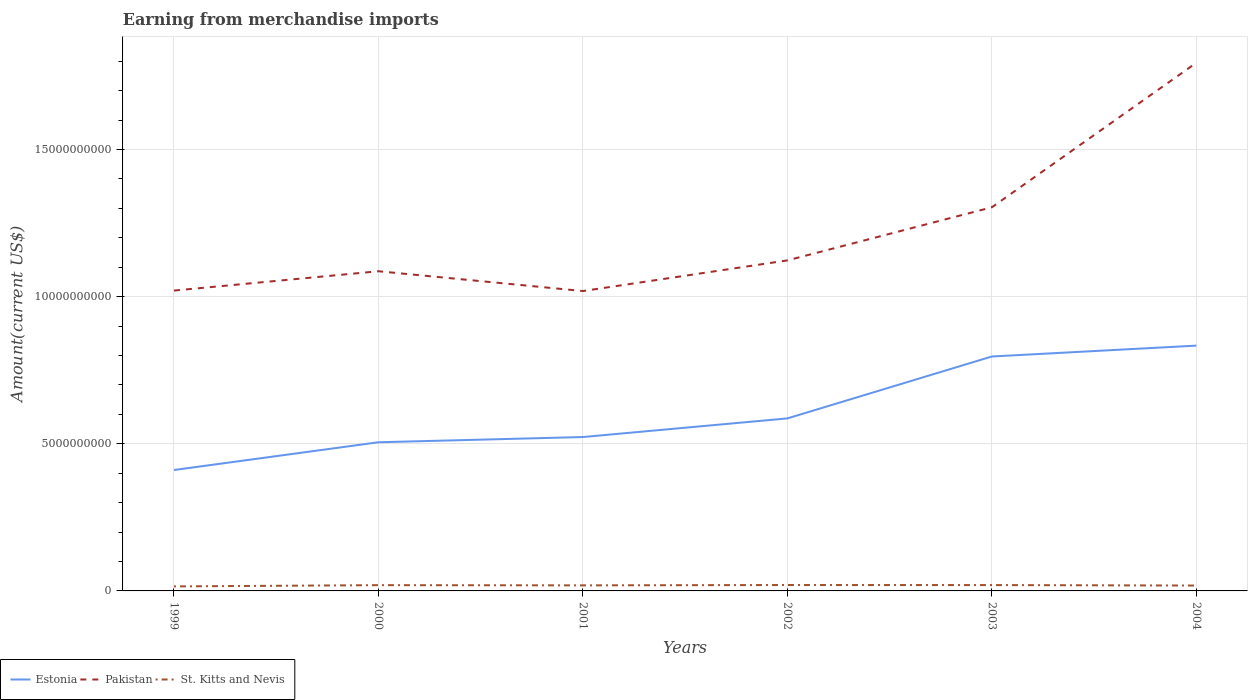How many different coloured lines are there?
Keep it short and to the point. 3. Is the number of lines equal to the number of legend labels?
Make the answer very short. Yes. Across all years, what is the maximum amount earned from merchandise imports in St. Kitts and Nevis?
Provide a short and direct response. 1.53e+08. In which year was the amount earned from merchandise imports in St. Kitts and Nevis maximum?
Provide a succinct answer. 1999. What is the total amount earned from merchandise imports in Estonia in the graph?
Your answer should be very brief. -6.33e+08. What is the difference between the highest and the second highest amount earned from merchandise imports in St. Kitts and Nevis?
Make the answer very short. 4.80e+07. Is the amount earned from merchandise imports in St. Kitts and Nevis strictly greater than the amount earned from merchandise imports in Estonia over the years?
Offer a very short reply. Yes. Are the values on the major ticks of Y-axis written in scientific E-notation?
Ensure brevity in your answer.  No. Does the graph contain grids?
Your response must be concise. Yes. How many legend labels are there?
Offer a very short reply. 3. What is the title of the graph?
Offer a terse response. Earning from merchandise imports. What is the label or title of the Y-axis?
Provide a short and direct response. Amount(current US$). What is the Amount(current US$) in Estonia in 1999?
Give a very brief answer. 4.11e+09. What is the Amount(current US$) of Pakistan in 1999?
Your answer should be compact. 1.02e+1. What is the Amount(current US$) of St. Kitts and Nevis in 1999?
Give a very brief answer. 1.53e+08. What is the Amount(current US$) in Estonia in 2000?
Ensure brevity in your answer.  5.05e+09. What is the Amount(current US$) in Pakistan in 2000?
Make the answer very short. 1.09e+1. What is the Amount(current US$) in St. Kitts and Nevis in 2000?
Your answer should be very brief. 1.96e+08. What is the Amount(current US$) of Estonia in 2001?
Offer a very short reply. 5.23e+09. What is the Amount(current US$) of Pakistan in 2001?
Your answer should be very brief. 1.02e+1. What is the Amount(current US$) in St. Kitts and Nevis in 2001?
Your response must be concise. 1.89e+08. What is the Amount(current US$) of Estonia in 2002?
Offer a very short reply. 5.86e+09. What is the Amount(current US$) of Pakistan in 2002?
Ensure brevity in your answer.  1.12e+1. What is the Amount(current US$) of St. Kitts and Nevis in 2002?
Provide a succinct answer. 2.01e+08. What is the Amount(current US$) of Estonia in 2003?
Make the answer very short. 7.97e+09. What is the Amount(current US$) of Pakistan in 2003?
Offer a very short reply. 1.30e+1. What is the Amount(current US$) of St. Kitts and Nevis in 2003?
Give a very brief answer. 1.99e+08. What is the Amount(current US$) of Estonia in 2004?
Ensure brevity in your answer.  8.34e+09. What is the Amount(current US$) in Pakistan in 2004?
Provide a succinct answer. 1.79e+1. What is the Amount(current US$) of St. Kitts and Nevis in 2004?
Make the answer very short. 1.83e+08. Across all years, what is the maximum Amount(current US$) of Estonia?
Your answer should be very brief. 8.34e+09. Across all years, what is the maximum Amount(current US$) in Pakistan?
Ensure brevity in your answer.  1.79e+1. Across all years, what is the maximum Amount(current US$) in St. Kitts and Nevis?
Offer a terse response. 2.01e+08. Across all years, what is the minimum Amount(current US$) of Estonia?
Your response must be concise. 4.11e+09. Across all years, what is the minimum Amount(current US$) of Pakistan?
Your answer should be compact. 1.02e+1. Across all years, what is the minimum Amount(current US$) in St. Kitts and Nevis?
Your answer should be very brief. 1.53e+08. What is the total Amount(current US$) of Estonia in the graph?
Offer a terse response. 3.66e+1. What is the total Amount(current US$) in Pakistan in the graph?
Ensure brevity in your answer.  7.35e+1. What is the total Amount(current US$) of St. Kitts and Nevis in the graph?
Your response must be concise. 1.12e+09. What is the difference between the Amount(current US$) in Estonia in 1999 and that in 2000?
Make the answer very short. -9.43e+08. What is the difference between the Amount(current US$) in Pakistan in 1999 and that in 2000?
Offer a terse response. -6.57e+08. What is the difference between the Amount(current US$) in St. Kitts and Nevis in 1999 and that in 2000?
Your answer should be very brief. -4.30e+07. What is the difference between the Amount(current US$) in Estonia in 1999 and that in 2001?
Make the answer very short. -1.12e+09. What is the difference between the Amount(current US$) in Pakistan in 1999 and that in 2001?
Keep it short and to the point. 1.60e+07. What is the difference between the Amount(current US$) of St. Kitts and Nevis in 1999 and that in 2001?
Your response must be concise. -3.60e+07. What is the difference between the Amount(current US$) of Estonia in 1999 and that in 2002?
Make the answer very short. -1.75e+09. What is the difference between the Amount(current US$) in Pakistan in 1999 and that in 2002?
Offer a terse response. -1.03e+09. What is the difference between the Amount(current US$) of St. Kitts and Nevis in 1999 and that in 2002?
Your answer should be compact. -4.80e+07. What is the difference between the Amount(current US$) in Estonia in 1999 and that in 2003?
Your answer should be compact. -3.86e+09. What is the difference between the Amount(current US$) in Pakistan in 1999 and that in 2003?
Offer a terse response. -2.83e+09. What is the difference between the Amount(current US$) in St. Kitts and Nevis in 1999 and that in 2003?
Give a very brief answer. -4.60e+07. What is the difference between the Amount(current US$) in Estonia in 1999 and that in 2004?
Keep it short and to the point. -4.23e+09. What is the difference between the Amount(current US$) in Pakistan in 1999 and that in 2004?
Give a very brief answer. -7.74e+09. What is the difference between the Amount(current US$) in St. Kitts and Nevis in 1999 and that in 2004?
Provide a short and direct response. -2.97e+07. What is the difference between the Amount(current US$) in Estonia in 2000 and that in 2001?
Your answer should be compact. -1.78e+08. What is the difference between the Amount(current US$) in Pakistan in 2000 and that in 2001?
Offer a terse response. 6.73e+08. What is the difference between the Amount(current US$) of Estonia in 2000 and that in 2002?
Ensure brevity in your answer.  -8.11e+08. What is the difference between the Amount(current US$) in Pakistan in 2000 and that in 2002?
Offer a very short reply. -3.69e+08. What is the difference between the Amount(current US$) in St. Kitts and Nevis in 2000 and that in 2002?
Make the answer very short. -5.00e+06. What is the difference between the Amount(current US$) in Estonia in 2000 and that in 2003?
Keep it short and to the point. -2.92e+09. What is the difference between the Amount(current US$) in Pakistan in 2000 and that in 2003?
Ensure brevity in your answer.  -2.17e+09. What is the difference between the Amount(current US$) of Estonia in 2000 and that in 2004?
Offer a terse response. -3.28e+09. What is the difference between the Amount(current US$) in Pakistan in 2000 and that in 2004?
Your answer should be compact. -7.08e+09. What is the difference between the Amount(current US$) of St. Kitts and Nevis in 2000 and that in 2004?
Provide a short and direct response. 1.33e+07. What is the difference between the Amount(current US$) in Estonia in 2001 and that in 2002?
Ensure brevity in your answer.  -6.33e+08. What is the difference between the Amount(current US$) of Pakistan in 2001 and that in 2002?
Your answer should be very brief. -1.04e+09. What is the difference between the Amount(current US$) of St. Kitts and Nevis in 2001 and that in 2002?
Provide a succinct answer. -1.20e+07. What is the difference between the Amount(current US$) in Estonia in 2001 and that in 2003?
Your answer should be compact. -2.74e+09. What is the difference between the Amount(current US$) of Pakistan in 2001 and that in 2003?
Provide a succinct answer. -2.85e+09. What is the difference between the Amount(current US$) of St. Kitts and Nevis in 2001 and that in 2003?
Offer a very short reply. -1.00e+07. What is the difference between the Amount(current US$) in Estonia in 2001 and that in 2004?
Keep it short and to the point. -3.11e+09. What is the difference between the Amount(current US$) in Pakistan in 2001 and that in 2004?
Ensure brevity in your answer.  -7.76e+09. What is the difference between the Amount(current US$) in St. Kitts and Nevis in 2001 and that in 2004?
Your answer should be compact. 6.32e+06. What is the difference between the Amount(current US$) in Estonia in 2002 and that in 2003?
Provide a short and direct response. -2.10e+09. What is the difference between the Amount(current US$) in Pakistan in 2002 and that in 2003?
Your answer should be very brief. -1.80e+09. What is the difference between the Amount(current US$) of Estonia in 2002 and that in 2004?
Your answer should be very brief. -2.47e+09. What is the difference between the Amount(current US$) of Pakistan in 2002 and that in 2004?
Make the answer very short. -6.72e+09. What is the difference between the Amount(current US$) of St. Kitts and Nevis in 2002 and that in 2004?
Offer a very short reply. 1.83e+07. What is the difference between the Amount(current US$) of Estonia in 2003 and that in 2004?
Offer a very short reply. -3.69e+08. What is the difference between the Amount(current US$) of Pakistan in 2003 and that in 2004?
Your answer should be compact. -4.91e+09. What is the difference between the Amount(current US$) in St. Kitts and Nevis in 2003 and that in 2004?
Your answer should be very brief. 1.63e+07. What is the difference between the Amount(current US$) in Estonia in 1999 and the Amount(current US$) in Pakistan in 2000?
Keep it short and to the point. -6.76e+09. What is the difference between the Amount(current US$) in Estonia in 1999 and the Amount(current US$) in St. Kitts and Nevis in 2000?
Your answer should be compact. 3.91e+09. What is the difference between the Amount(current US$) in Pakistan in 1999 and the Amount(current US$) in St. Kitts and Nevis in 2000?
Your response must be concise. 1.00e+1. What is the difference between the Amount(current US$) of Estonia in 1999 and the Amount(current US$) of Pakistan in 2001?
Make the answer very short. -6.08e+09. What is the difference between the Amount(current US$) of Estonia in 1999 and the Amount(current US$) of St. Kitts and Nevis in 2001?
Ensure brevity in your answer.  3.92e+09. What is the difference between the Amount(current US$) of Pakistan in 1999 and the Amount(current US$) of St. Kitts and Nevis in 2001?
Your answer should be very brief. 1.00e+1. What is the difference between the Amount(current US$) of Estonia in 1999 and the Amount(current US$) of Pakistan in 2002?
Your answer should be compact. -7.12e+09. What is the difference between the Amount(current US$) in Estonia in 1999 and the Amount(current US$) in St. Kitts and Nevis in 2002?
Make the answer very short. 3.91e+09. What is the difference between the Amount(current US$) of Pakistan in 1999 and the Amount(current US$) of St. Kitts and Nevis in 2002?
Provide a short and direct response. 1.00e+1. What is the difference between the Amount(current US$) in Estonia in 1999 and the Amount(current US$) in Pakistan in 2003?
Provide a short and direct response. -8.93e+09. What is the difference between the Amount(current US$) in Estonia in 1999 and the Amount(current US$) in St. Kitts and Nevis in 2003?
Give a very brief answer. 3.91e+09. What is the difference between the Amount(current US$) of Pakistan in 1999 and the Amount(current US$) of St. Kitts and Nevis in 2003?
Give a very brief answer. 1.00e+1. What is the difference between the Amount(current US$) of Estonia in 1999 and the Amount(current US$) of Pakistan in 2004?
Make the answer very short. -1.38e+1. What is the difference between the Amount(current US$) of Estonia in 1999 and the Amount(current US$) of St. Kitts and Nevis in 2004?
Keep it short and to the point. 3.93e+09. What is the difference between the Amount(current US$) in Pakistan in 1999 and the Amount(current US$) in St. Kitts and Nevis in 2004?
Your answer should be very brief. 1.00e+1. What is the difference between the Amount(current US$) of Estonia in 2000 and the Amount(current US$) of Pakistan in 2001?
Keep it short and to the point. -5.14e+09. What is the difference between the Amount(current US$) in Estonia in 2000 and the Amount(current US$) in St. Kitts and Nevis in 2001?
Offer a very short reply. 4.86e+09. What is the difference between the Amount(current US$) of Pakistan in 2000 and the Amount(current US$) of St. Kitts and Nevis in 2001?
Keep it short and to the point. 1.07e+1. What is the difference between the Amount(current US$) of Estonia in 2000 and the Amount(current US$) of Pakistan in 2002?
Make the answer very short. -6.18e+09. What is the difference between the Amount(current US$) of Estonia in 2000 and the Amount(current US$) of St. Kitts and Nevis in 2002?
Your answer should be compact. 4.85e+09. What is the difference between the Amount(current US$) of Pakistan in 2000 and the Amount(current US$) of St. Kitts and Nevis in 2002?
Your answer should be very brief. 1.07e+1. What is the difference between the Amount(current US$) of Estonia in 2000 and the Amount(current US$) of Pakistan in 2003?
Provide a succinct answer. -7.99e+09. What is the difference between the Amount(current US$) of Estonia in 2000 and the Amount(current US$) of St. Kitts and Nevis in 2003?
Keep it short and to the point. 4.85e+09. What is the difference between the Amount(current US$) in Pakistan in 2000 and the Amount(current US$) in St. Kitts and Nevis in 2003?
Your answer should be compact. 1.07e+1. What is the difference between the Amount(current US$) in Estonia in 2000 and the Amount(current US$) in Pakistan in 2004?
Make the answer very short. -1.29e+1. What is the difference between the Amount(current US$) in Estonia in 2000 and the Amount(current US$) in St. Kitts and Nevis in 2004?
Make the answer very short. 4.87e+09. What is the difference between the Amount(current US$) in Pakistan in 2000 and the Amount(current US$) in St. Kitts and Nevis in 2004?
Your response must be concise. 1.07e+1. What is the difference between the Amount(current US$) in Estonia in 2001 and the Amount(current US$) in Pakistan in 2002?
Your answer should be compact. -6.00e+09. What is the difference between the Amount(current US$) of Estonia in 2001 and the Amount(current US$) of St. Kitts and Nevis in 2002?
Ensure brevity in your answer.  5.03e+09. What is the difference between the Amount(current US$) in Pakistan in 2001 and the Amount(current US$) in St. Kitts and Nevis in 2002?
Ensure brevity in your answer.  9.99e+09. What is the difference between the Amount(current US$) in Estonia in 2001 and the Amount(current US$) in Pakistan in 2003?
Your answer should be very brief. -7.81e+09. What is the difference between the Amount(current US$) in Estonia in 2001 and the Amount(current US$) in St. Kitts and Nevis in 2003?
Provide a short and direct response. 5.03e+09. What is the difference between the Amount(current US$) of Pakistan in 2001 and the Amount(current US$) of St. Kitts and Nevis in 2003?
Ensure brevity in your answer.  9.99e+09. What is the difference between the Amount(current US$) in Estonia in 2001 and the Amount(current US$) in Pakistan in 2004?
Provide a short and direct response. -1.27e+1. What is the difference between the Amount(current US$) of Estonia in 2001 and the Amount(current US$) of St. Kitts and Nevis in 2004?
Your response must be concise. 5.05e+09. What is the difference between the Amount(current US$) of Pakistan in 2001 and the Amount(current US$) of St. Kitts and Nevis in 2004?
Ensure brevity in your answer.  1.00e+1. What is the difference between the Amount(current US$) in Estonia in 2002 and the Amount(current US$) in Pakistan in 2003?
Provide a short and direct response. -7.18e+09. What is the difference between the Amount(current US$) of Estonia in 2002 and the Amount(current US$) of St. Kitts and Nevis in 2003?
Make the answer very short. 5.66e+09. What is the difference between the Amount(current US$) in Pakistan in 2002 and the Amount(current US$) in St. Kitts and Nevis in 2003?
Ensure brevity in your answer.  1.10e+1. What is the difference between the Amount(current US$) in Estonia in 2002 and the Amount(current US$) in Pakistan in 2004?
Give a very brief answer. -1.21e+1. What is the difference between the Amount(current US$) in Estonia in 2002 and the Amount(current US$) in St. Kitts and Nevis in 2004?
Provide a short and direct response. 5.68e+09. What is the difference between the Amount(current US$) of Pakistan in 2002 and the Amount(current US$) of St. Kitts and Nevis in 2004?
Offer a terse response. 1.11e+1. What is the difference between the Amount(current US$) of Estonia in 2003 and the Amount(current US$) of Pakistan in 2004?
Give a very brief answer. -9.98e+09. What is the difference between the Amount(current US$) of Estonia in 2003 and the Amount(current US$) of St. Kitts and Nevis in 2004?
Ensure brevity in your answer.  7.78e+09. What is the difference between the Amount(current US$) of Pakistan in 2003 and the Amount(current US$) of St. Kitts and Nevis in 2004?
Keep it short and to the point. 1.29e+1. What is the average Amount(current US$) of Estonia per year?
Offer a very short reply. 6.09e+09. What is the average Amount(current US$) in Pakistan per year?
Ensure brevity in your answer.  1.22e+1. What is the average Amount(current US$) of St. Kitts and Nevis per year?
Make the answer very short. 1.87e+08. In the year 1999, what is the difference between the Amount(current US$) of Estonia and Amount(current US$) of Pakistan?
Provide a succinct answer. -6.10e+09. In the year 1999, what is the difference between the Amount(current US$) in Estonia and Amount(current US$) in St. Kitts and Nevis?
Make the answer very short. 3.96e+09. In the year 1999, what is the difference between the Amount(current US$) of Pakistan and Amount(current US$) of St. Kitts and Nevis?
Provide a short and direct response. 1.01e+1. In the year 2000, what is the difference between the Amount(current US$) in Estonia and Amount(current US$) in Pakistan?
Offer a very short reply. -5.81e+09. In the year 2000, what is the difference between the Amount(current US$) of Estonia and Amount(current US$) of St. Kitts and Nevis?
Provide a succinct answer. 4.86e+09. In the year 2000, what is the difference between the Amount(current US$) in Pakistan and Amount(current US$) in St. Kitts and Nevis?
Your response must be concise. 1.07e+1. In the year 2001, what is the difference between the Amount(current US$) in Estonia and Amount(current US$) in Pakistan?
Provide a succinct answer. -4.96e+09. In the year 2001, what is the difference between the Amount(current US$) in Estonia and Amount(current US$) in St. Kitts and Nevis?
Offer a very short reply. 5.04e+09. In the year 2001, what is the difference between the Amount(current US$) in Pakistan and Amount(current US$) in St. Kitts and Nevis?
Offer a terse response. 1.00e+1. In the year 2002, what is the difference between the Amount(current US$) in Estonia and Amount(current US$) in Pakistan?
Your response must be concise. -5.37e+09. In the year 2002, what is the difference between the Amount(current US$) in Estonia and Amount(current US$) in St. Kitts and Nevis?
Ensure brevity in your answer.  5.66e+09. In the year 2002, what is the difference between the Amount(current US$) of Pakistan and Amount(current US$) of St. Kitts and Nevis?
Provide a succinct answer. 1.10e+1. In the year 2003, what is the difference between the Amount(current US$) in Estonia and Amount(current US$) in Pakistan?
Keep it short and to the point. -5.07e+09. In the year 2003, what is the difference between the Amount(current US$) of Estonia and Amount(current US$) of St. Kitts and Nevis?
Keep it short and to the point. 7.77e+09. In the year 2003, what is the difference between the Amount(current US$) of Pakistan and Amount(current US$) of St. Kitts and Nevis?
Offer a very short reply. 1.28e+1. In the year 2004, what is the difference between the Amount(current US$) in Estonia and Amount(current US$) in Pakistan?
Your response must be concise. -9.61e+09. In the year 2004, what is the difference between the Amount(current US$) in Estonia and Amount(current US$) in St. Kitts and Nevis?
Make the answer very short. 8.15e+09. In the year 2004, what is the difference between the Amount(current US$) of Pakistan and Amount(current US$) of St. Kitts and Nevis?
Provide a short and direct response. 1.78e+1. What is the ratio of the Amount(current US$) in Estonia in 1999 to that in 2000?
Your answer should be compact. 0.81. What is the ratio of the Amount(current US$) in Pakistan in 1999 to that in 2000?
Make the answer very short. 0.94. What is the ratio of the Amount(current US$) of St. Kitts and Nevis in 1999 to that in 2000?
Ensure brevity in your answer.  0.78. What is the ratio of the Amount(current US$) in Estonia in 1999 to that in 2001?
Make the answer very short. 0.79. What is the ratio of the Amount(current US$) of Pakistan in 1999 to that in 2001?
Keep it short and to the point. 1. What is the ratio of the Amount(current US$) in St. Kitts and Nevis in 1999 to that in 2001?
Give a very brief answer. 0.81. What is the ratio of the Amount(current US$) of Estonia in 1999 to that in 2002?
Your answer should be very brief. 0.7. What is the ratio of the Amount(current US$) in Pakistan in 1999 to that in 2002?
Offer a very short reply. 0.91. What is the ratio of the Amount(current US$) of St. Kitts and Nevis in 1999 to that in 2002?
Your answer should be very brief. 0.76. What is the ratio of the Amount(current US$) of Estonia in 1999 to that in 2003?
Offer a very short reply. 0.52. What is the ratio of the Amount(current US$) in Pakistan in 1999 to that in 2003?
Your response must be concise. 0.78. What is the ratio of the Amount(current US$) in St. Kitts and Nevis in 1999 to that in 2003?
Make the answer very short. 0.77. What is the ratio of the Amount(current US$) of Estonia in 1999 to that in 2004?
Your answer should be very brief. 0.49. What is the ratio of the Amount(current US$) of Pakistan in 1999 to that in 2004?
Offer a very short reply. 0.57. What is the ratio of the Amount(current US$) in St. Kitts and Nevis in 1999 to that in 2004?
Provide a succinct answer. 0.84. What is the ratio of the Amount(current US$) of Pakistan in 2000 to that in 2001?
Your answer should be compact. 1.07. What is the ratio of the Amount(current US$) in Estonia in 2000 to that in 2002?
Give a very brief answer. 0.86. What is the ratio of the Amount(current US$) in Pakistan in 2000 to that in 2002?
Provide a succinct answer. 0.97. What is the ratio of the Amount(current US$) in St. Kitts and Nevis in 2000 to that in 2002?
Provide a short and direct response. 0.98. What is the ratio of the Amount(current US$) in Estonia in 2000 to that in 2003?
Ensure brevity in your answer.  0.63. What is the ratio of the Amount(current US$) in Pakistan in 2000 to that in 2003?
Offer a terse response. 0.83. What is the ratio of the Amount(current US$) of St. Kitts and Nevis in 2000 to that in 2003?
Keep it short and to the point. 0.98. What is the ratio of the Amount(current US$) in Estonia in 2000 to that in 2004?
Your answer should be very brief. 0.61. What is the ratio of the Amount(current US$) in Pakistan in 2000 to that in 2004?
Provide a succinct answer. 0.61. What is the ratio of the Amount(current US$) of St. Kitts and Nevis in 2000 to that in 2004?
Keep it short and to the point. 1.07. What is the ratio of the Amount(current US$) of Estonia in 2001 to that in 2002?
Your response must be concise. 0.89. What is the ratio of the Amount(current US$) in Pakistan in 2001 to that in 2002?
Ensure brevity in your answer.  0.91. What is the ratio of the Amount(current US$) of St. Kitts and Nevis in 2001 to that in 2002?
Offer a very short reply. 0.94. What is the ratio of the Amount(current US$) of Estonia in 2001 to that in 2003?
Make the answer very short. 0.66. What is the ratio of the Amount(current US$) of Pakistan in 2001 to that in 2003?
Your answer should be very brief. 0.78. What is the ratio of the Amount(current US$) of St. Kitts and Nevis in 2001 to that in 2003?
Provide a succinct answer. 0.95. What is the ratio of the Amount(current US$) in Estonia in 2001 to that in 2004?
Keep it short and to the point. 0.63. What is the ratio of the Amount(current US$) in Pakistan in 2001 to that in 2004?
Your answer should be compact. 0.57. What is the ratio of the Amount(current US$) of St. Kitts and Nevis in 2001 to that in 2004?
Keep it short and to the point. 1.03. What is the ratio of the Amount(current US$) in Estonia in 2002 to that in 2003?
Ensure brevity in your answer.  0.74. What is the ratio of the Amount(current US$) of Pakistan in 2002 to that in 2003?
Ensure brevity in your answer.  0.86. What is the ratio of the Amount(current US$) of St. Kitts and Nevis in 2002 to that in 2003?
Your answer should be very brief. 1.01. What is the ratio of the Amount(current US$) in Estonia in 2002 to that in 2004?
Keep it short and to the point. 0.7. What is the ratio of the Amount(current US$) in Pakistan in 2002 to that in 2004?
Offer a very short reply. 0.63. What is the ratio of the Amount(current US$) in St. Kitts and Nevis in 2002 to that in 2004?
Your response must be concise. 1.1. What is the ratio of the Amount(current US$) in Estonia in 2003 to that in 2004?
Provide a succinct answer. 0.96. What is the ratio of the Amount(current US$) of Pakistan in 2003 to that in 2004?
Offer a terse response. 0.73. What is the ratio of the Amount(current US$) of St. Kitts and Nevis in 2003 to that in 2004?
Provide a short and direct response. 1.09. What is the difference between the highest and the second highest Amount(current US$) in Estonia?
Your answer should be compact. 3.69e+08. What is the difference between the highest and the second highest Amount(current US$) of Pakistan?
Your answer should be very brief. 4.91e+09. What is the difference between the highest and the lowest Amount(current US$) of Estonia?
Provide a succinct answer. 4.23e+09. What is the difference between the highest and the lowest Amount(current US$) of Pakistan?
Your answer should be very brief. 7.76e+09. What is the difference between the highest and the lowest Amount(current US$) of St. Kitts and Nevis?
Make the answer very short. 4.80e+07. 